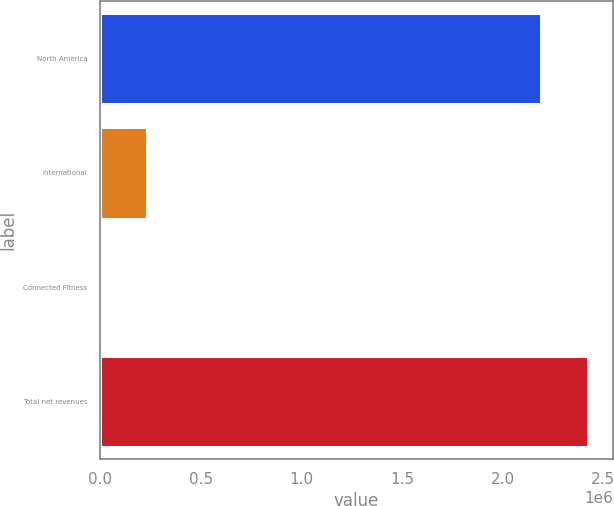<chart> <loc_0><loc_0><loc_500><loc_500><bar_chart><fcel>North America<fcel>International<fcel>Connected Fitness<fcel>Total net revenues<nl><fcel>2.19374e+06<fcel>234166<fcel>1068<fcel>2.42684e+06<nl></chart> 